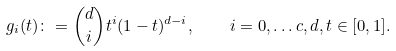Convert formula to latex. <formula><loc_0><loc_0><loc_500><loc_500>g _ { i } ( t ) \colon = { d \choose i } t ^ { i } ( 1 - t ) ^ { d - i } , \quad i = 0 , \dots c , d , t \in [ 0 , 1 ] .</formula> 